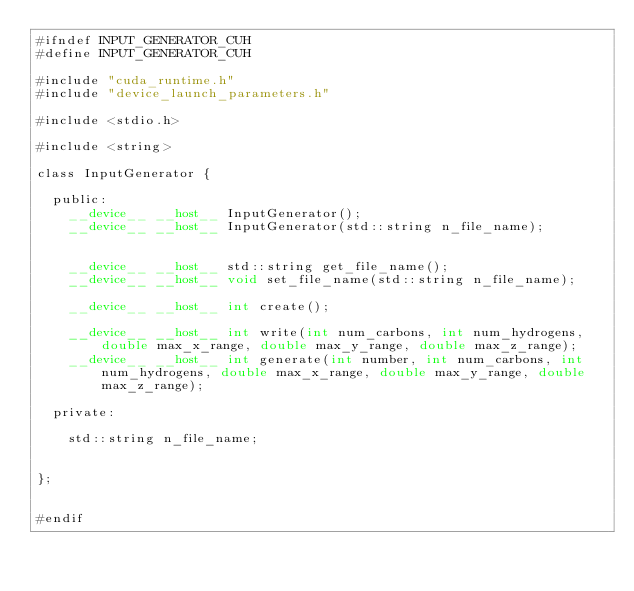Convert code to text. <code><loc_0><loc_0><loc_500><loc_500><_Cuda_>#ifndef INPUT_GENERATOR_CUH
#define INPUT_GENERATOR_CUH

#include "cuda_runtime.h"
#include "device_launch_parameters.h"

#include <stdio.h>

#include <string>

class InputGenerator {

	public:
		__device__ __host__ InputGenerator();
		__device__ __host__ InputGenerator(std::string n_file_name);


		__device__ __host__ std::string get_file_name();
		__device__ __host__ void set_file_name(std::string n_file_name);

		__device__ __host__ int create();

		__device__ __host__ int write(int num_carbons, int num_hydrogens, double max_x_range, double max_y_range, double max_z_range);
		__device__ __host__ int generate(int number, int num_carbons, int num_hydrogens, double max_x_range, double max_y_range, double max_z_range);

	private:

		std::string n_file_name;


};


#endif

</code> 